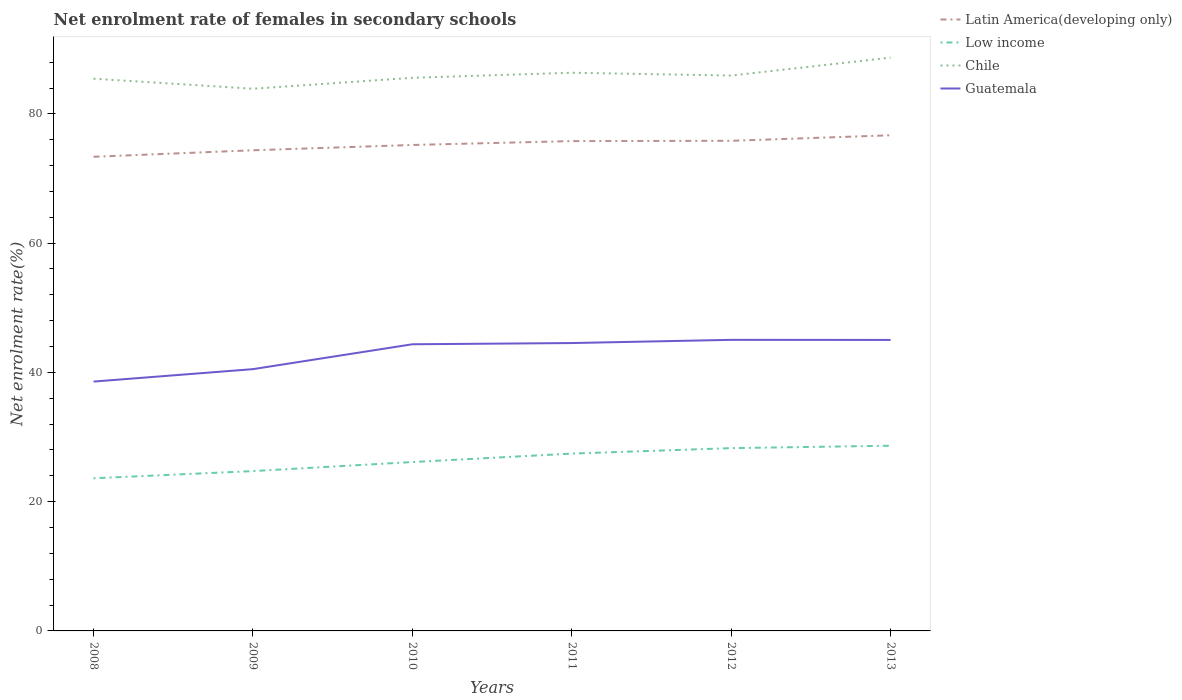How many different coloured lines are there?
Your answer should be compact. 4. Is the number of lines equal to the number of legend labels?
Your answer should be compact. Yes. Across all years, what is the maximum net enrolment rate of females in secondary schools in Low income?
Provide a short and direct response. 23.62. What is the total net enrolment rate of females in secondary schools in Chile in the graph?
Ensure brevity in your answer.  -0.92. What is the difference between the highest and the second highest net enrolment rate of females in secondary schools in Latin America(developing only)?
Offer a very short reply. 3.33. Is the net enrolment rate of females in secondary schools in Chile strictly greater than the net enrolment rate of females in secondary schools in Low income over the years?
Provide a succinct answer. No. How many years are there in the graph?
Ensure brevity in your answer.  6. What is the difference between two consecutive major ticks on the Y-axis?
Keep it short and to the point. 20. How many legend labels are there?
Provide a short and direct response. 4. What is the title of the graph?
Offer a very short reply. Net enrolment rate of females in secondary schools. What is the label or title of the X-axis?
Keep it short and to the point. Years. What is the label or title of the Y-axis?
Make the answer very short. Net enrolment rate(%). What is the Net enrolment rate(%) of Latin America(developing only) in 2008?
Give a very brief answer. 73.36. What is the Net enrolment rate(%) in Low income in 2008?
Offer a terse response. 23.62. What is the Net enrolment rate(%) in Chile in 2008?
Keep it short and to the point. 85.44. What is the Net enrolment rate(%) in Guatemala in 2008?
Keep it short and to the point. 38.58. What is the Net enrolment rate(%) of Latin America(developing only) in 2009?
Offer a very short reply. 74.37. What is the Net enrolment rate(%) in Low income in 2009?
Offer a terse response. 24.73. What is the Net enrolment rate(%) of Chile in 2009?
Your answer should be compact. 83.89. What is the Net enrolment rate(%) of Guatemala in 2009?
Provide a short and direct response. 40.5. What is the Net enrolment rate(%) in Latin America(developing only) in 2010?
Your response must be concise. 75.19. What is the Net enrolment rate(%) in Low income in 2010?
Provide a succinct answer. 26.13. What is the Net enrolment rate(%) in Chile in 2010?
Offer a very short reply. 85.58. What is the Net enrolment rate(%) of Guatemala in 2010?
Give a very brief answer. 44.35. What is the Net enrolment rate(%) of Latin America(developing only) in 2011?
Ensure brevity in your answer.  75.79. What is the Net enrolment rate(%) of Low income in 2011?
Keep it short and to the point. 27.44. What is the Net enrolment rate(%) in Chile in 2011?
Offer a terse response. 86.37. What is the Net enrolment rate(%) of Guatemala in 2011?
Offer a terse response. 44.54. What is the Net enrolment rate(%) of Latin America(developing only) in 2012?
Provide a succinct answer. 75.83. What is the Net enrolment rate(%) of Low income in 2012?
Ensure brevity in your answer.  28.28. What is the Net enrolment rate(%) of Chile in 2012?
Offer a very short reply. 85.93. What is the Net enrolment rate(%) of Guatemala in 2012?
Provide a succinct answer. 45.04. What is the Net enrolment rate(%) of Latin America(developing only) in 2013?
Offer a very short reply. 76.69. What is the Net enrolment rate(%) of Low income in 2013?
Your response must be concise. 28.66. What is the Net enrolment rate(%) in Chile in 2013?
Ensure brevity in your answer.  88.71. What is the Net enrolment rate(%) of Guatemala in 2013?
Your answer should be very brief. 45.02. Across all years, what is the maximum Net enrolment rate(%) of Latin America(developing only)?
Your answer should be compact. 76.69. Across all years, what is the maximum Net enrolment rate(%) in Low income?
Your answer should be compact. 28.66. Across all years, what is the maximum Net enrolment rate(%) in Chile?
Your response must be concise. 88.71. Across all years, what is the maximum Net enrolment rate(%) in Guatemala?
Your answer should be compact. 45.04. Across all years, what is the minimum Net enrolment rate(%) of Latin America(developing only)?
Your response must be concise. 73.36. Across all years, what is the minimum Net enrolment rate(%) of Low income?
Make the answer very short. 23.62. Across all years, what is the minimum Net enrolment rate(%) of Chile?
Give a very brief answer. 83.89. Across all years, what is the minimum Net enrolment rate(%) in Guatemala?
Offer a terse response. 38.58. What is the total Net enrolment rate(%) in Latin America(developing only) in the graph?
Provide a succinct answer. 451.23. What is the total Net enrolment rate(%) of Low income in the graph?
Your answer should be very brief. 158.85. What is the total Net enrolment rate(%) in Chile in the graph?
Provide a succinct answer. 515.92. What is the total Net enrolment rate(%) of Guatemala in the graph?
Ensure brevity in your answer.  258.04. What is the difference between the Net enrolment rate(%) of Latin America(developing only) in 2008 and that in 2009?
Provide a short and direct response. -1.01. What is the difference between the Net enrolment rate(%) in Low income in 2008 and that in 2009?
Give a very brief answer. -1.11. What is the difference between the Net enrolment rate(%) in Chile in 2008 and that in 2009?
Make the answer very short. 1.55. What is the difference between the Net enrolment rate(%) of Guatemala in 2008 and that in 2009?
Keep it short and to the point. -1.92. What is the difference between the Net enrolment rate(%) in Latin America(developing only) in 2008 and that in 2010?
Offer a very short reply. -1.83. What is the difference between the Net enrolment rate(%) in Low income in 2008 and that in 2010?
Keep it short and to the point. -2.51. What is the difference between the Net enrolment rate(%) in Chile in 2008 and that in 2010?
Ensure brevity in your answer.  -0.14. What is the difference between the Net enrolment rate(%) of Guatemala in 2008 and that in 2010?
Your response must be concise. -5.77. What is the difference between the Net enrolment rate(%) in Latin America(developing only) in 2008 and that in 2011?
Keep it short and to the point. -2.43. What is the difference between the Net enrolment rate(%) of Low income in 2008 and that in 2011?
Provide a short and direct response. -3.82. What is the difference between the Net enrolment rate(%) of Chile in 2008 and that in 2011?
Give a very brief answer. -0.92. What is the difference between the Net enrolment rate(%) in Guatemala in 2008 and that in 2011?
Your answer should be very brief. -5.96. What is the difference between the Net enrolment rate(%) in Latin America(developing only) in 2008 and that in 2012?
Your response must be concise. -2.47. What is the difference between the Net enrolment rate(%) of Low income in 2008 and that in 2012?
Your answer should be compact. -4.66. What is the difference between the Net enrolment rate(%) of Chile in 2008 and that in 2012?
Give a very brief answer. -0.49. What is the difference between the Net enrolment rate(%) in Guatemala in 2008 and that in 2012?
Your response must be concise. -6.46. What is the difference between the Net enrolment rate(%) of Latin America(developing only) in 2008 and that in 2013?
Provide a short and direct response. -3.33. What is the difference between the Net enrolment rate(%) in Low income in 2008 and that in 2013?
Your answer should be compact. -5.04. What is the difference between the Net enrolment rate(%) in Chile in 2008 and that in 2013?
Provide a short and direct response. -3.26. What is the difference between the Net enrolment rate(%) of Guatemala in 2008 and that in 2013?
Offer a terse response. -6.44. What is the difference between the Net enrolment rate(%) of Latin America(developing only) in 2009 and that in 2010?
Your response must be concise. -0.82. What is the difference between the Net enrolment rate(%) in Low income in 2009 and that in 2010?
Make the answer very short. -1.4. What is the difference between the Net enrolment rate(%) of Chile in 2009 and that in 2010?
Ensure brevity in your answer.  -1.69. What is the difference between the Net enrolment rate(%) of Guatemala in 2009 and that in 2010?
Provide a short and direct response. -3.85. What is the difference between the Net enrolment rate(%) of Latin America(developing only) in 2009 and that in 2011?
Keep it short and to the point. -1.42. What is the difference between the Net enrolment rate(%) of Low income in 2009 and that in 2011?
Provide a short and direct response. -2.71. What is the difference between the Net enrolment rate(%) of Chile in 2009 and that in 2011?
Provide a succinct answer. -2.48. What is the difference between the Net enrolment rate(%) in Guatemala in 2009 and that in 2011?
Provide a succinct answer. -4.04. What is the difference between the Net enrolment rate(%) in Latin America(developing only) in 2009 and that in 2012?
Your answer should be compact. -1.46. What is the difference between the Net enrolment rate(%) of Low income in 2009 and that in 2012?
Give a very brief answer. -3.55. What is the difference between the Net enrolment rate(%) of Chile in 2009 and that in 2012?
Provide a succinct answer. -2.04. What is the difference between the Net enrolment rate(%) in Guatemala in 2009 and that in 2012?
Give a very brief answer. -4.53. What is the difference between the Net enrolment rate(%) in Latin America(developing only) in 2009 and that in 2013?
Give a very brief answer. -2.32. What is the difference between the Net enrolment rate(%) in Low income in 2009 and that in 2013?
Offer a terse response. -3.93. What is the difference between the Net enrolment rate(%) in Chile in 2009 and that in 2013?
Ensure brevity in your answer.  -4.82. What is the difference between the Net enrolment rate(%) of Guatemala in 2009 and that in 2013?
Provide a short and direct response. -4.52. What is the difference between the Net enrolment rate(%) in Latin America(developing only) in 2010 and that in 2011?
Offer a terse response. -0.6. What is the difference between the Net enrolment rate(%) in Low income in 2010 and that in 2011?
Offer a very short reply. -1.31. What is the difference between the Net enrolment rate(%) in Chile in 2010 and that in 2011?
Offer a terse response. -0.78. What is the difference between the Net enrolment rate(%) in Guatemala in 2010 and that in 2011?
Offer a terse response. -0.19. What is the difference between the Net enrolment rate(%) of Latin America(developing only) in 2010 and that in 2012?
Give a very brief answer. -0.65. What is the difference between the Net enrolment rate(%) in Low income in 2010 and that in 2012?
Provide a succinct answer. -2.15. What is the difference between the Net enrolment rate(%) of Chile in 2010 and that in 2012?
Your answer should be compact. -0.35. What is the difference between the Net enrolment rate(%) in Guatemala in 2010 and that in 2012?
Provide a short and direct response. -0.68. What is the difference between the Net enrolment rate(%) in Latin America(developing only) in 2010 and that in 2013?
Your answer should be compact. -1.5. What is the difference between the Net enrolment rate(%) of Low income in 2010 and that in 2013?
Give a very brief answer. -2.53. What is the difference between the Net enrolment rate(%) of Chile in 2010 and that in 2013?
Offer a terse response. -3.12. What is the difference between the Net enrolment rate(%) of Guatemala in 2010 and that in 2013?
Keep it short and to the point. -0.67. What is the difference between the Net enrolment rate(%) in Latin America(developing only) in 2011 and that in 2012?
Your response must be concise. -0.04. What is the difference between the Net enrolment rate(%) in Low income in 2011 and that in 2012?
Your answer should be compact. -0.85. What is the difference between the Net enrolment rate(%) in Chile in 2011 and that in 2012?
Offer a terse response. 0.44. What is the difference between the Net enrolment rate(%) in Guatemala in 2011 and that in 2012?
Your response must be concise. -0.49. What is the difference between the Net enrolment rate(%) of Latin America(developing only) in 2011 and that in 2013?
Your answer should be very brief. -0.9. What is the difference between the Net enrolment rate(%) of Low income in 2011 and that in 2013?
Offer a very short reply. -1.22. What is the difference between the Net enrolment rate(%) of Chile in 2011 and that in 2013?
Provide a succinct answer. -2.34. What is the difference between the Net enrolment rate(%) of Guatemala in 2011 and that in 2013?
Give a very brief answer. -0.48. What is the difference between the Net enrolment rate(%) in Latin America(developing only) in 2012 and that in 2013?
Offer a terse response. -0.86. What is the difference between the Net enrolment rate(%) of Low income in 2012 and that in 2013?
Give a very brief answer. -0.37. What is the difference between the Net enrolment rate(%) of Chile in 2012 and that in 2013?
Your answer should be very brief. -2.78. What is the difference between the Net enrolment rate(%) in Guatemala in 2012 and that in 2013?
Your answer should be compact. 0.01. What is the difference between the Net enrolment rate(%) in Latin America(developing only) in 2008 and the Net enrolment rate(%) in Low income in 2009?
Ensure brevity in your answer.  48.63. What is the difference between the Net enrolment rate(%) of Latin America(developing only) in 2008 and the Net enrolment rate(%) of Chile in 2009?
Offer a terse response. -10.53. What is the difference between the Net enrolment rate(%) of Latin America(developing only) in 2008 and the Net enrolment rate(%) of Guatemala in 2009?
Ensure brevity in your answer.  32.86. What is the difference between the Net enrolment rate(%) in Low income in 2008 and the Net enrolment rate(%) in Chile in 2009?
Ensure brevity in your answer.  -60.27. What is the difference between the Net enrolment rate(%) of Low income in 2008 and the Net enrolment rate(%) of Guatemala in 2009?
Provide a short and direct response. -16.88. What is the difference between the Net enrolment rate(%) in Chile in 2008 and the Net enrolment rate(%) in Guatemala in 2009?
Your answer should be compact. 44.94. What is the difference between the Net enrolment rate(%) of Latin America(developing only) in 2008 and the Net enrolment rate(%) of Low income in 2010?
Keep it short and to the point. 47.23. What is the difference between the Net enrolment rate(%) of Latin America(developing only) in 2008 and the Net enrolment rate(%) of Chile in 2010?
Keep it short and to the point. -12.22. What is the difference between the Net enrolment rate(%) of Latin America(developing only) in 2008 and the Net enrolment rate(%) of Guatemala in 2010?
Your answer should be compact. 29.01. What is the difference between the Net enrolment rate(%) in Low income in 2008 and the Net enrolment rate(%) in Chile in 2010?
Give a very brief answer. -61.96. What is the difference between the Net enrolment rate(%) of Low income in 2008 and the Net enrolment rate(%) of Guatemala in 2010?
Ensure brevity in your answer.  -20.73. What is the difference between the Net enrolment rate(%) of Chile in 2008 and the Net enrolment rate(%) of Guatemala in 2010?
Your answer should be compact. 41.09. What is the difference between the Net enrolment rate(%) in Latin America(developing only) in 2008 and the Net enrolment rate(%) in Low income in 2011?
Ensure brevity in your answer.  45.92. What is the difference between the Net enrolment rate(%) in Latin America(developing only) in 2008 and the Net enrolment rate(%) in Chile in 2011?
Keep it short and to the point. -13.01. What is the difference between the Net enrolment rate(%) of Latin America(developing only) in 2008 and the Net enrolment rate(%) of Guatemala in 2011?
Offer a very short reply. 28.82. What is the difference between the Net enrolment rate(%) in Low income in 2008 and the Net enrolment rate(%) in Chile in 2011?
Your answer should be very brief. -62.75. What is the difference between the Net enrolment rate(%) in Low income in 2008 and the Net enrolment rate(%) in Guatemala in 2011?
Offer a terse response. -20.92. What is the difference between the Net enrolment rate(%) in Chile in 2008 and the Net enrolment rate(%) in Guatemala in 2011?
Provide a succinct answer. 40.9. What is the difference between the Net enrolment rate(%) in Latin America(developing only) in 2008 and the Net enrolment rate(%) in Low income in 2012?
Offer a very short reply. 45.08. What is the difference between the Net enrolment rate(%) in Latin America(developing only) in 2008 and the Net enrolment rate(%) in Chile in 2012?
Your response must be concise. -12.57. What is the difference between the Net enrolment rate(%) in Latin America(developing only) in 2008 and the Net enrolment rate(%) in Guatemala in 2012?
Your answer should be compact. 28.32. What is the difference between the Net enrolment rate(%) in Low income in 2008 and the Net enrolment rate(%) in Chile in 2012?
Provide a succinct answer. -62.31. What is the difference between the Net enrolment rate(%) of Low income in 2008 and the Net enrolment rate(%) of Guatemala in 2012?
Ensure brevity in your answer.  -21.42. What is the difference between the Net enrolment rate(%) of Chile in 2008 and the Net enrolment rate(%) of Guatemala in 2012?
Keep it short and to the point. 40.41. What is the difference between the Net enrolment rate(%) in Latin America(developing only) in 2008 and the Net enrolment rate(%) in Low income in 2013?
Provide a succinct answer. 44.71. What is the difference between the Net enrolment rate(%) of Latin America(developing only) in 2008 and the Net enrolment rate(%) of Chile in 2013?
Offer a very short reply. -15.35. What is the difference between the Net enrolment rate(%) of Latin America(developing only) in 2008 and the Net enrolment rate(%) of Guatemala in 2013?
Offer a terse response. 28.34. What is the difference between the Net enrolment rate(%) of Low income in 2008 and the Net enrolment rate(%) of Chile in 2013?
Provide a succinct answer. -65.09. What is the difference between the Net enrolment rate(%) of Low income in 2008 and the Net enrolment rate(%) of Guatemala in 2013?
Give a very brief answer. -21.4. What is the difference between the Net enrolment rate(%) of Chile in 2008 and the Net enrolment rate(%) of Guatemala in 2013?
Provide a short and direct response. 40.42. What is the difference between the Net enrolment rate(%) of Latin America(developing only) in 2009 and the Net enrolment rate(%) of Low income in 2010?
Your answer should be very brief. 48.24. What is the difference between the Net enrolment rate(%) in Latin America(developing only) in 2009 and the Net enrolment rate(%) in Chile in 2010?
Provide a succinct answer. -11.21. What is the difference between the Net enrolment rate(%) in Latin America(developing only) in 2009 and the Net enrolment rate(%) in Guatemala in 2010?
Offer a very short reply. 30.02. What is the difference between the Net enrolment rate(%) in Low income in 2009 and the Net enrolment rate(%) in Chile in 2010?
Keep it short and to the point. -60.85. What is the difference between the Net enrolment rate(%) of Low income in 2009 and the Net enrolment rate(%) of Guatemala in 2010?
Offer a terse response. -19.62. What is the difference between the Net enrolment rate(%) of Chile in 2009 and the Net enrolment rate(%) of Guatemala in 2010?
Give a very brief answer. 39.54. What is the difference between the Net enrolment rate(%) in Latin America(developing only) in 2009 and the Net enrolment rate(%) in Low income in 2011?
Offer a terse response. 46.93. What is the difference between the Net enrolment rate(%) of Latin America(developing only) in 2009 and the Net enrolment rate(%) of Chile in 2011?
Offer a terse response. -12. What is the difference between the Net enrolment rate(%) in Latin America(developing only) in 2009 and the Net enrolment rate(%) in Guatemala in 2011?
Provide a short and direct response. 29.83. What is the difference between the Net enrolment rate(%) in Low income in 2009 and the Net enrolment rate(%) in Chile in 2011?
Provide a short and direct response. -61.64. What is the difference between the Net enrolment rate(%) of Low income in 2009 and the Net enrolment rate(%) of Guatemala in 2011?
Give a very brief answer. -19.81. What is the difference between the Net enrolment rate(%) of Chile in 2009 and the Net enrolment rate(%) of Guatemala in 2011?
Your answer should be very brief. 39.35. What is the difference between the Net enrolment rate(%) of Latin America(developing only) in 2009 and the Net enrolment rate(%) of Low income in 2012?
Offer a terse response. 46.09. What is the difference between the Net enrolment rate(%) of Latin America(developing only) in 2009 and the Net enrolment rate(%) of Chile in 2012?
Keep it short and to the point. -11.56. What is the difference between the Net enrolment rate(%) of Latin America(developing only) in 2009 and the Net enrolment rate(%) of Guatemala in 2012?
Provide a short and direct response. 29.33. What is the difference between the Net enrolment rate(%) of Low income in 2009 and the Net enrolment rate(%) of Chile in 2012?
Provide a succinct answer. -61.2. What is the difference between the Net enrolment rate(%) of Low income in 2009 and the Net enrolment rate(%) of Guatemala in 2012?
Make the answer very short. -20.31. What is the difference between the Net enrolment rate(%) of Chile in 2009 and the Net enrolment rate(%) of Guatemala in 2012?
Your answer should be very brief. 38.85. What is the difference between the Net enrolment rate(%) of Latin America(developing only) in 2009 and the Net enrolment rate(%) of Low income in 2013?
Keep it short and to the point. 45.72. What is the difference between the Net enrolment rate(%) of Latin America(developing only) in 2009 and the Net enrolment rate(%) of Chile in 2013?
Make the answer very short. -14.34. What is the difference between the Net enrolment rate(%) in Latin America(developing only) in 2009 and the Net enrolment rate(%) in Guatemala in 2013?
Offer a very short reply. 29.35. What is the difference between the Net enrolment rate(%) in Low income in 2009 and the Net enrolment rate(%) in Chile in 2013?
Your answer should be compact. -63.98. What is the difference between the Net enrolment rate(%) of Low income in 2009 and the Net enrolment rate(%) of Guatemala in 2013?
Offer a very short reply. -20.29. What is the difference between the Net enrolment rate(%) in Chile in 2009 and the Net enrolment rate(%) in Guatemala in 2013?
Your answer should be compact. 38.87. What is the difference between the Net enrolment rate(%) of Latin America(developing only) in 2010 and the Net enrolment rate(%) of Low income in 2011?
Offer a terse response. 47.75. What is the difference between the Net enrolment rate(%) in Latin America(developing only) in 2010 and the Net enrolment rate(%) in Chile in 2011?
Ensure brevity in your answer.  -11.18. What is the difference between the Net enrolment rate(%) in Latin America(developing only) in 2010 and the Net enrolment rate(%) in Guatemala in 2011?
Your answer should be compact. 30.65. What is the difference between the Net enrolment rate(%) of Low income in 2010 and the Net enrolment rate(%) of Chile in 2011?
Your answer should be compact. -60.24. What is the difference between the Net enrolment rate(%) in Low income in 2010 and the Net enrolment rate(%) in Guatemala in 2011?
Provide a succinct answer. -18.41. What is the difference between the Net enrolment rate(%) in Chile in 2010 and the Net enrolment rate(%) in Guatemala in 2011?
Ensure brevity in your answer.  41.04. What is the difference between the Net enrolment rate(%) in Latin America(developing only) in 2010 and the Net enrolment rate(%) in Low income in 2012?
Offer a terse response. 46.9. What is the difference between the Net enrolment rate(%) of Latin America(developing only) in 2010 and the Net enrolment rate(%) of Chile in 2012?
Your answer should be compact. -10.74. What is the difference between the Net enrolment rate(%) of Latin America(developing only) in 2010 and the Net enrolment rate(%) of Guatemala in 2012?
Your response must be concise. 30.15. What is the difference between the Net enrolment rate(%) in Low income in 2010 and the Net enrolment rate(%) in Chile in 2012?
Give a very brief answer. -59.8. What is the difference between the Net enrolment rate(%) of Low income in 2010 and the Net enrolment rate(%) of Guatemala in 2012?
Your answer should be compact. -18.91. What is the difference between the Net enrolment rate(%) in Chile in 2010 and the Net enrolment rate(%) in Guatemala in 2012?
Your answer should be very brief. 40.55. What is the difference between the Net enrolment rate(%) of Latin America(developing only) in 2010 and the Net enrolment rate(%) of Low income in 2013?
Your response must be concise. 46.53. What is the difference between the Net enrolment rate(%) in Latin America(developing only) in 2010 and the Net enrolment rate(%) in Chile in 2013?
Keep it short and to the point. -13.52. What is the difference between the Net enrolment rate(%) in Latin America(developing only) in 2010 and the Net enrolment rate(%) in Guatemala in 2013?
Provide a short and direct response. 30.16. What is the difference between the Net enrolment rate(%) in Low income in 2010 and the Net enrolment rate(%) in Chile in 2013?
Offer a very short reply. -62.58. What is the difference between the Net enrolment rate(%) in Low income in 2010 and the Net enrolment rate(%) in Guatemala in 2013?
Offer a terse response. -18.89. What is the difference between the Net enrolment rate(%) of Chile in 2010 and the Net enrolment rate(%) of Guatemala in 2013?
Your response must be concise. 40.56. What is the difference between the Net enrolment rate(%) in Latin America(developing only) in 2011 and the Net enrolment rate(%) in Low income in 2012?
Make the answer very short. 47.51. What is the difference between the Net enrolment rate(%) in Latin America(developing only) in 2011 and the Net enrolment rate(%) in Chile in 2012?
Offer a very short reply. -10.14. What is the difference between the Net enrolment rate(%) in Latin America(developing only) in 2011 and the Net enrolment rate(%) in Guatemala in 2012?
Offer a terse response. 30.75. What is the difference between the Net enrolment rate(%) of Low income in 2011 and the Net enrolment rate(%) of Chile in 2012?
Give a very brief answer. -58.49. What is the difference between the Net enrolment rate(%) of Low income in 2011 and the Net enrolment rate(%) of Guatemala in 2012?
Your answer should be very brief. -17.6. What is the difference between the Net enrolment rate(%) of Chile in 2011 and the Net enrolment rate(%) of Guatemala in 2012?
Give a very brief answer. 41.33. What is the difference between the Net enrolment rate(%) of Latin America(developing only) in 2011 and the Net enrolment rate(%) of Low income in 2013?
Offer a very short reply. 47.13. What is the difference between the Net enrolment rate(%) in Latin America(developing only) in 2011 and the Net enrolment rate(%) in Chile in 2013?
Give a very brief answer. -12.92. What is the difference between the Net enrolment rate(%) of Latin America(developing only) in 2011 and the Net enrolment rate(%) of Guatemala in 2013?
Provide a short and direct response. 30.77. What is the difference between the Net enrolment rate(%) in Low income in 2011 and the Net enrolment rate(%) in Chile in 2013?
Provide a short and direct response. -61.27. What is the difference between the Net enrolment rate(%) of Low income in 2011 and the Net enrolment rate(%) of Guatemala in 2013?
Offer a terse response. -17.59. What is the difference between the Net enrolment rate(%) of Chile in 2011 and the Net enrolment rate(%) of Guatemala in 2013?
Keep it short and to the point. 41.34. What is the difference between the Net enrolment rate(%) in Latin America(developing only) in 2012 and the Net enrolment rate(%) in Low income in 2013?
Offer a terse response. 47.18. What is the difference between the Net enrolment rate(%) in Latin America(developing only) in 2012 and the Net enrolment rate(%) in Chile in 2013?
Provide a succinct answer. -12.87. What is the difference between the Net enrolment rate(%) in Latin America(developing only) in 2012 and the Net enrolment rate(%) in Guatemala in 2013?
Your answer should be compact. 30.81. What is the difference between the Net enrolment rate(%) of Low income in 2012 and the Net enrolment rate(%) of Chile in 2013?
Your answer should be compact. -60.42. What is the difference between the Net enrolment rate(%) in Low income in 2012 and the Net enrolment rate(%) in Guatemala in 2013?
Provide a short and direct response. -16.74. What is the difference between the Net enrolment rate(%) in Chile in 2012 and the Net enrolment rate(%) in Guatemala in 2013?
Make the answer very short. 40.91. What is the average Net enrolment rate(%) in Latin America(developing only) per year?
Offer a very short reply. 75.21. What is the average Net enrolment rate(%) in Low income per year?
Give a very brief answer. 26.48. What is the average Net enrolment rate(%) in Chile per year?
Offer a very short reply. 85.99. What is the average Net enrolment rate(%) of Guatemala per year?
Give a very brief answer. 43.01. In the year 2008, what is the difference between the Net enrolment rate(%) of Latin America(developing only) and Net enrolment rate(%) of Low income?
Offer a terse response. 49.74. In the year 2008, what is the difference between the Net enrolment rate(%) in Latin America(developing only) and Net enrolment rate(%) in Chile?
Offer a terse response. -12.08. In the year 2008, what is the difference between the Net enrolment rate(%) of Latin America(developing only) and Net enrolment rate(%) of Guatemala?
Ensure brevity in your answer.  34.78. In the year 2008, what is the difference between the Net enrolment rate(%) in Low income and Net enrolment rate(%) in Chile?
Your answer should be very brief. -61.82. In the year 2008, what is the difference between the Net enrolment rate(%) of Low income and Net enrolment rate(%) of Guatemala?
Offer a terse response. -14.96. In the year 2008, what is the difference between the Net enrolment rate(%) of Chile and Net enrolment rate(%) of Guatemala?
Your answer should be compact. 46.86. In the year 2009, what is the difference between the Net enrolment rate(%) of Latin America(developing only) and Net enrolment rate(%) of Low income?
Give a very brief answer. 49.64. In the year 2009, what is the difference between the Net enrolment rate(%) in Latin America(developing only) and Net enrolment rate(%) in Chile?
Provide a succinct answer. -9.52. In the year 2009, what is the difference between the Net enrolment rate(%) of Latin America(developing only) and Net enrolment rate(%) of Guatemala?
Provide a short and direct response. 33.87. In the year 2009, what is the difference between the Net enrolment rate(%) of Low income and Net enrolment rate(%) of Chile?
Provide a succinct answer. -59.16. In the year 2009, what is the difference between the Net enrolment rate(%) in Low income and Net enrolment rate(%) in Guatemala?
Keep it short and to the point. -15.77. In the year 2009, what is the difference between the Net enrolment rate(%) of Chile and Net enrolment rate(%) of Guatemala?
Offer a very short reply. 43.39. In the year 2010, what is the difference between the Net enrolment rate(%) of Latin America(developing only) and Net enrolment rate(%) of Low income?
Ensure brevity in your answer.  49.06. In the year 2010, what is the difference between the Net enrolment rate(%) of Latin America(developing only) and Net enrolment rate(%) of Chile?
Provide a succinct answer. -10.4. In the year 2010, what is the difference between the Net enrolment rate(%) of Latin America(developing only) and Net enrolment rate(%) of Guatemala?
Your response must be concise. 30.83. In the year 2010, what is the difference between the Net enrolment rate(%) in Low income and Net enrolment rate(%) in Chile?
Give a very brief answer. -59.45. In the year 2010, what is the difference between the Net enrolment rate(%) in Low income and Net enrolment rate(%) in Guatemala?
Make the answer very short. -18.22. In the year 2010, what is the difference between the Net enrolment rate(%) of Chile and Net enrolment rate(%) of Guatemala?
Give a very brief answer. 41.23. In the year 2011, what is the difference between the Net enrolment rate(%) in Latin America(developing only) and Net enrolment rate(%) in Low income?
Make the answer very short. 48.35. In the year 2011, what is the difference between the Net enrolment rate(%) in Latin America(developing only) and Net enrolment rate(%) in Chile?
Provide a succinct answer. -10.58. In the year 2011, what is the difference between the Net enrolment rate(%) in Latin America(developing only) and Net enrolment rate(%) in Guatemala?
Provide a succinct answer. 31.25. In the year 2011, what is the difference between the Net enrolment rate(%) of Low income and Net enrolment rate(%) of Chile?
Offer a terse response. -58.93. In the year 2011, what is the difference between the Net enrolment rate(%) in Low income and Net enrolment rate(%) in Guatemala?
Offer a very short reply. -17.1. In the year 2011, what is the difference between the Net enrolment rate(%) of Chile and Net enrolment rate(%) of Guatemala?
Offer a terse response. 41.83. In the year 2012, what is the difference between the Net enrolment rate(%) of Latin America(developing only) and Net enrolment rate(%) of Low income?
Your response must be concise. 47.55. In the year 2012, what is the difference between the Net enrolment rate(%) in Latin America(developing only) and Net enrolment rate(%) in Chile?
Give a very brief answer. -10.1. In the year 2012, what is the difference between the Net enrolment rate(%) in Latin America(developing only) and Net enrolment rate(%) in Guatemala?
Your answer should be very brief. 30.8. In the year 2012, what is the difference between the Net enrolment rate(%) of Low income and Net enrolment rate(%) of Chile?
Your response must be concise. -57.65. In the year 2012, what is the difference between the Net enrolment rate(%) of Low income and Net enrolment rate(%) of Guatemala?
Provide a short and direct response. -16.75. In the year 2012, what is the difference between the Net enrolment rate(%) of Chile and Net enrolment rate(%) of Guatemala?
Your answer should be very brief. 40.89. In the year 2013, what is the difference between the Net enrolment rate(%) of Latin America(developing only) and Net enrolment rate(%) of Low income?
Your answer should be very brief. 48.04. In the year 2013, what is the difference between the Net enrolment rate(%) in Latin America(developing only) and Net enrolment rate(%) in Chile?
Provide a succinct answer. -12.02. In the year 2013, what is the difference between the Net enrolment rate(%) of Latin America(developing only) and Net enrolment rate(%) of Guatemala?
Keep it short and to the point. 31.67. In the year 2013, what is the difference between the Net enrolment rate(%) in Low income and Net enrolment rate(%) in Chile?
Ensure brevity in your answer.  -60.05. In the year 2013, what is the difference between the Net enrolment rate(%) in Low income and Net enrolment rate(%) in Guatemala?
Ensure brevity in your answer.  -16.37. In the year 2013, what is the difference between the Net enrolment rate(%) of Chile and Net enrolment rate(%) of Guatemala?
Give a very brief answer. 43.68. What is the ratio of the Net enrolment rate(%) of Latin America(developing only) in 2008 to that in 2009?
Give a very brief answer. 0.99. What is the ratio of the Net enrolment rate(%) of Low income in 2008 to that in 2009?
Provide a succinct answer. 0.96. What is the ratio of the Net enrolment rate(%) of Chile in 2008 to that in 2009?
Provide a short and direct response. 1.02. What is the ratio of the Net enrolment rate(%) in Guatemala in 2008 to that in 2009?
Keep it short and to the point. 0.95. What is the ratio of the Net enrolment rate(%) of Latin America(developing only) in 2008 to that in 2010?
Offer a terse response. 0.98. What is the ratio of the Net enrolment rate(%) of Low income in 2008 to that in 2010?
Keep it short and to the point. 0.9. What is the ratio of the Net enrolment rate(%) of Guatemala in 2008 to that in 2010?
Provide a short and direct response. 0.87. What is the ratio of the Net enrolment rate(%) of Low income in 2008 to that in 2011?
Give a very brief answer. 0.86. What is the ratio of the Net enrolment rate(%) in Chile in 2008 to that in 2011?
Ensure brevity in your answer.  0.99. What is the ratio of the Net enrolment rate(%) of Guatemala in 2008 to that in 2011?
Make the answer very short. 0.87. What is the ratio of the Net enrolment rate(%) in Latin America(developing only) in 2008 to that in 2012?
Make the answer very short. 0.97. What is the ratio of the Net enrolment rate(%) in Low income in 2008 to that in 2012?
Offer a very short reply. 0.84. What is the ratio of the Net enrolment rate(%) of Guatemala in 2008 to that in 2012?
Provide a short and direct response. 0.86. What is the ratio of the Net enrolment rate(%) of Latin America(developing only) in 2008 to that in 2013?
Provide a short and direct response. 0.96. What is the ratio of the Net enrolment rate(%) in Low income in 2008 to that in 2013?
Your response must be concise. 0.82. What is the ratio of the Net enrolment rate(%) of Chile in 2008 to that in 2013?
Provide a succinct answer. 0.96. What is the ratio of the Net enrolment rate(%) in Guatemala in 2008 to that in 2013?
Your answer should be very brief. 0.86. What is the ratio of the Net enrolment rate(%) in Low income in 2009 to that in 2010?
Offer a terse response. 0.95. What is the ratio of the Net enrolment rate(%) in Chile in 2009 to that in 2010?
Make the answer very short. 0.98. What is the ratio of the Net enrolment rate(%) in Guatemala in 2009 to that in 2010?
Your answer should be very brief. 0.91. What is the ratio of the Net enrolment rate(%) in Latin America(developing only) in 2009 to that in 2011?
Your response must be concise. 0.98. What is the ratio of the Net enrolment rate(%) in Low income in 2009 to that in 2011?
Your answer should be compact. 0.9. What is the ratio of the Net enrolment rate(%) of Chile in 2009 to that in 2011?
Offer a very short reply. 0.97. What is the ratio of the Net enrolment rate(%) of Guatemala in 2009 to that in 2011?
Your answer should be compact. 0.91. What is the ratio of the Net enrolment rate(%) in Latin America(developing only) in 2009 to that in 2012?
Give a very brief answer. 0.98. What is the ratio of the Net enrolment rate(%) of Low income in 2009 to that in 2012?
Your response must be concise. 0.87. What is the ratio of the Net enrolment rate(%) of Chile in 2009 to that in 2012?
Your response must be concise. 0.98. What is the ratio of the Net enrolment rate(%) in Guatemala in 2009 to that in 2012?
Offer a very short reply. 0.9. What is the ratio of the Net enrolment rate(%) of Latin America(developing only) in 2009 to that in 2013?
Make the answer very short. 0.97. What is the ratio of the Net enrolment rate(%) of Low income in 2009 to that in 2013?
Make the answer very short. 0.86. What is the ratio of the Net enrolment rate(%) of Chile in 2009 to that in 2013?
Provide a succinct answer. 0.95. What is the ratio of the Net enrolment rate(%) of Guatemala in 2009 to that in 2013?
Keep it short and to the point. 0.9. What is the ratio of the Net enrolment rate(%) in Latin America(developing only) in 2010 to that in 2011?
Give a very brief answer. 0.99. What is the ratio of the Net enrolment rate(%) of Low income in 2010 to that in 2011?
Offer a terse response. 0.95. What is the ratio of the Net enrolment rate(%) in Chile in 2010 to that in 2011?
Provide a succinct answer. 0.99. What is the ratio of the Net enrolment rate(%) of Guatemala in 2010 to that in 2011?
Ensure brevity in your answer.  1. What is the ratio of the Net enrolment rate(%) of Low income in 2010 to that in 2012?
Offer a terse response. 0.92. What is the ratio of the Net enrolment rate(%) of Chile in 2010 to that in 2012?
Your answer should be compact. 1. What is the ratio of the Net enrolment rate(%) in Guatemala in 2010 to that in 2012?
Keep it short and to the point. 0.98. What is the ratio of the Net enrolment rate(%) in Latin America(developing only) in 2010 to that in 2013?
Give a very brief answer. 0.98. What is the ratio of the Net enrolment rate(%) in Low income in 2010 to that in 2013?
Give a very brief answer. 0.91. What is the ratio of the Net enrolment rate(%) in Chile in 2010 to that in 2013?
Keep it short and to the point. 0.96. What is the ratio of the Net enrolment rate(%) in Guatemala in 2010 to that in 2013?
Give a very brief answer. 0.99. What is the ratio of the Net enrolment rate(%) of Latin America(developing only) in 2011 to that in 2012?
Offer a very short reply. 1. What is the ratio of the Net enrolment rate(%) in Low income in 2011 to that in 2012?
Your response must be concise. 0.97. What is the ratio of the Net enrolment rate(%) of Chile in 2011 to that in 2012?
Provide a short and direct response. 1.01. What is the ratio of the Net enrolment rate(%) in Guatemala in 2011 to that in 2012?
Give a very brief answer. 0.99. What is the ratio of the Net enrolment rate(%) in Latin America(developing only) in 2011 to that in 2013?
Your response must be concise. 0.99. What is the ratio of the Net enrolment rate(%) of Low income in 2011 to that in 2013?
Your response must be concise. 0.96. What is the ratio of the Net enrolment rate(%) of Chile in 2011 to that in 2013?
Ensure brevity in your answer.  0.97. What is the ratio of the Net enrolment rate(%) in Guatemala in 2011 to that in 2013?
Offer a terse response. 0.99. What is the ratio of the Net enrolment rate(%) of Latin America(developing only) in 2012 to that in 2013?
Give a very brief answer. 0.99. What is the ratio of the Net enrolment rate(%) in Low income in 2012 to that in 2013?
Offer a very short reply. 0.99. What is the ratio of the Net enrolment rate(%) in Chile in 2012 to that in 2013?
Your answer should be very brief. 0.97. What is the difference between the highest and the second highest Net enrolment rate(%) in Latin America(developing only)?
Keep it short and to the point. 0.86. What is the difference between the highest and the second highest Net enrolment rate(%) in Low income?
Provide a succinct answer. 0.37. What is the difference between the highest and the second highest Net enrolment rate(%) of Chile?
Offer a terse response. 2.34. What is the difference between the highest and the second highest Net enrolment rate(%) of Guatemala?
Keep it short and to the point. 0.01. What is the difference between the highest and the lowest Net enrolment rate(%) of Latin America(developing only)?
Ensure brevity in your answer.  3.33. What is the difference between the highest and the lowest Net enrolment rate(%) in Low income?
Your response must be concise. 5.04. What is the difference between the highest and the lowest Net enrolment rate(%) in Chile?
Ensure brevity in your answer.  4.82. What is the difference between the highest and the lowest Net enrolment rate(%) in Guatemala?
Provide a succinct answer. 6.46. 